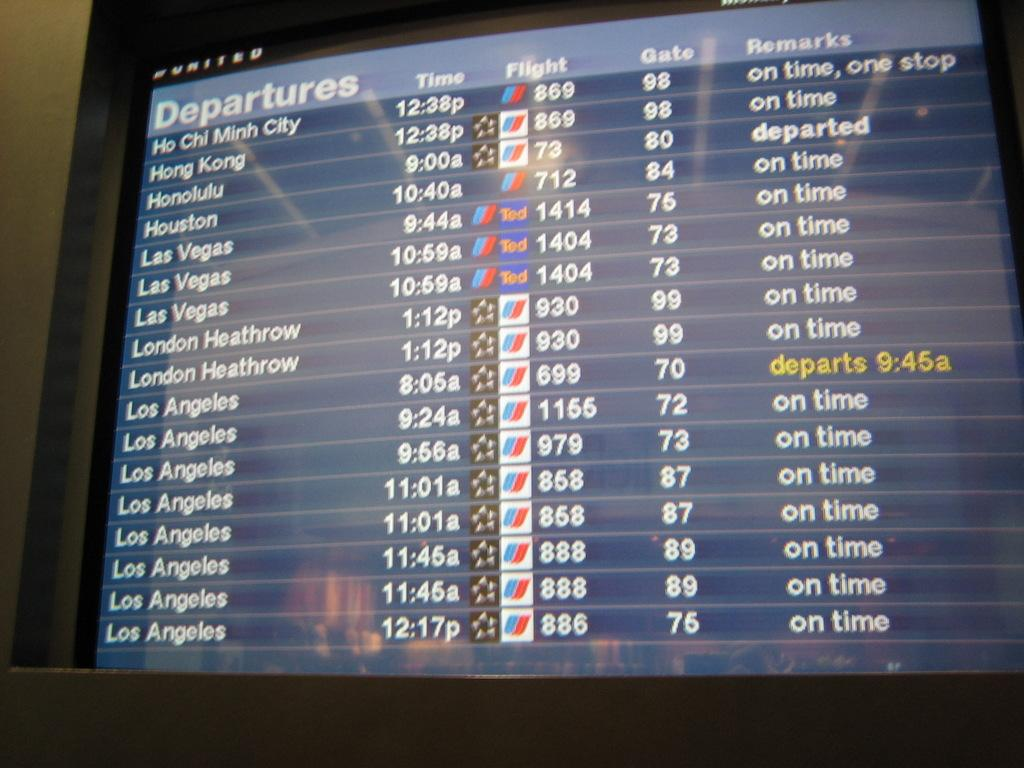<image>
Present a compact description of the photo's key features. a screen with all the departures being displayed on it 